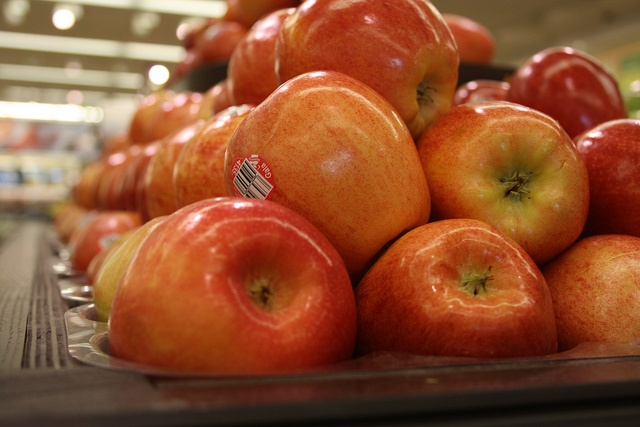Describe the objects in this image and their specific colors. I can see apple in olive, brown, red, and maroon tones, apple in olive, red, maroon, and tan tones, apple in olive, maroon, brown, and red tones, apple in olive, red, and maroon tones, and apple in olive, brown, maroon, and tan tones in this image. 